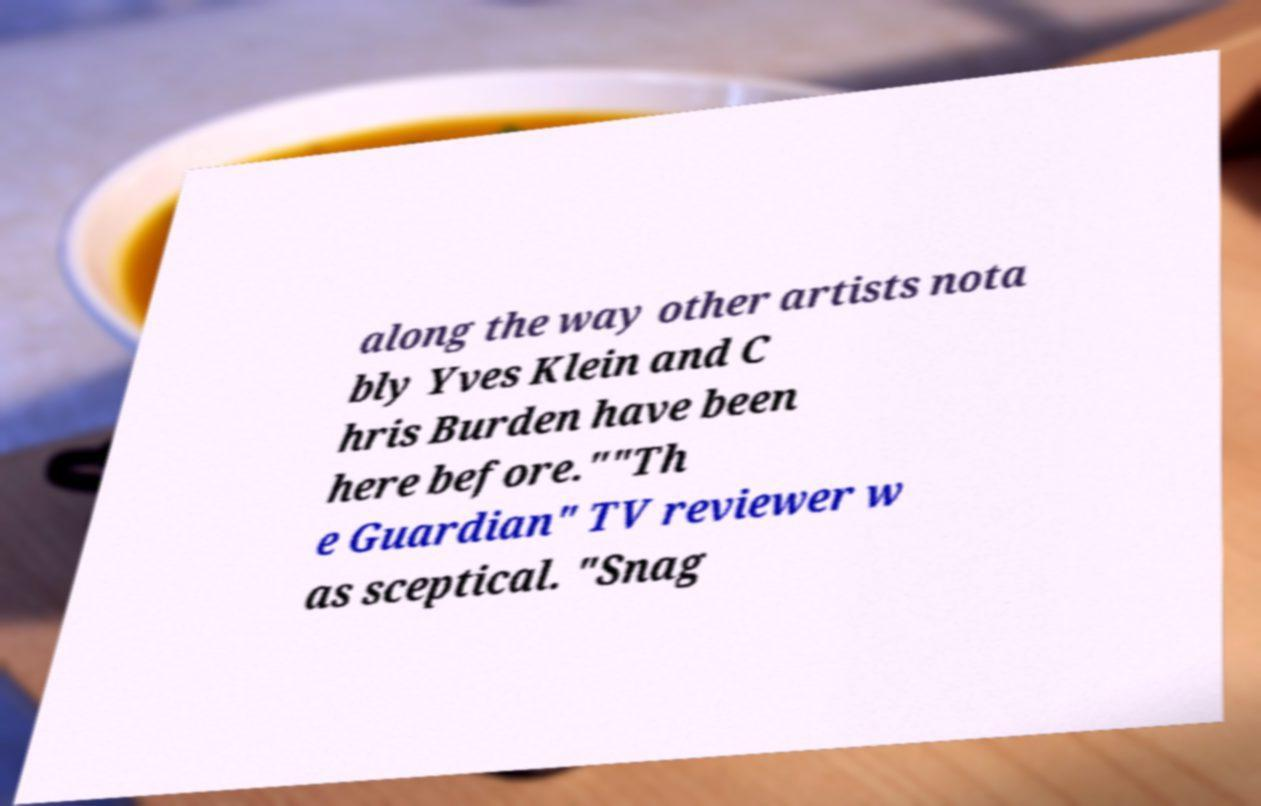There's text embedded in this image that I need extracted. Can you transcribe it verbatim? along the way other artists nota bly Yves Klein and C hris Burden have been here before.""Th e Guardian" TV reviewer w as sceptical. "Snag 